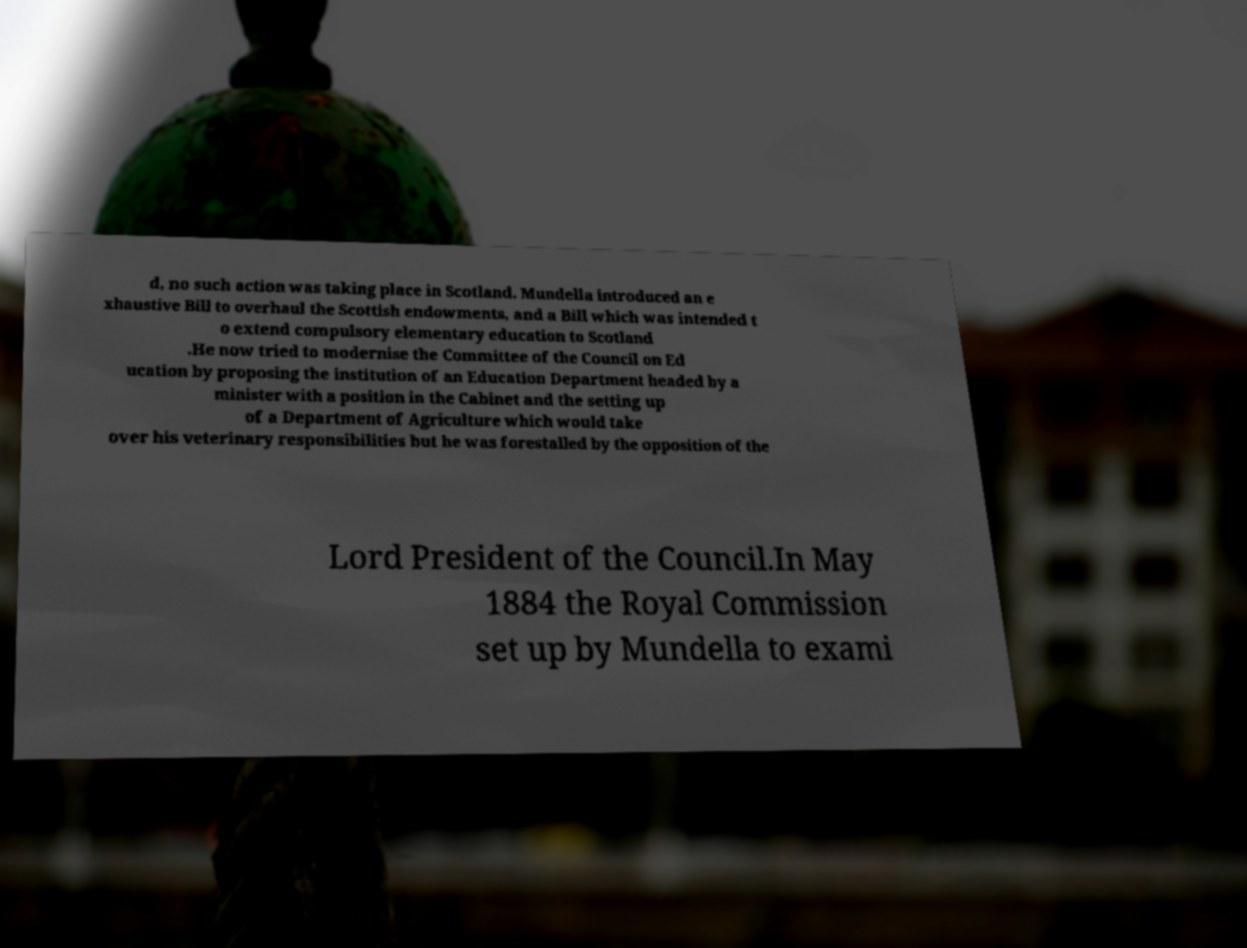For documentation purposes, I need the text within this image transcribed. Could you provide that? d, no such action was taking place in Scotland. Mundella introduced an e xhaustive Bill to overhaul the Scottish endowments, and a Bill which was intended t o extend compulsory elementary education to Scotland .He now tried to modernise the Committee of the Council on Ed ucation by proposing the institution of an Education Department headed by a minister with a position in the Cabinet and the setting up of a Department of Agriculture which would take over his veterinary responsibilities but he was forestalled by the opposition of the Lord President of the Council.In May 1884 the Royal Commission set up by Mundella to exami 